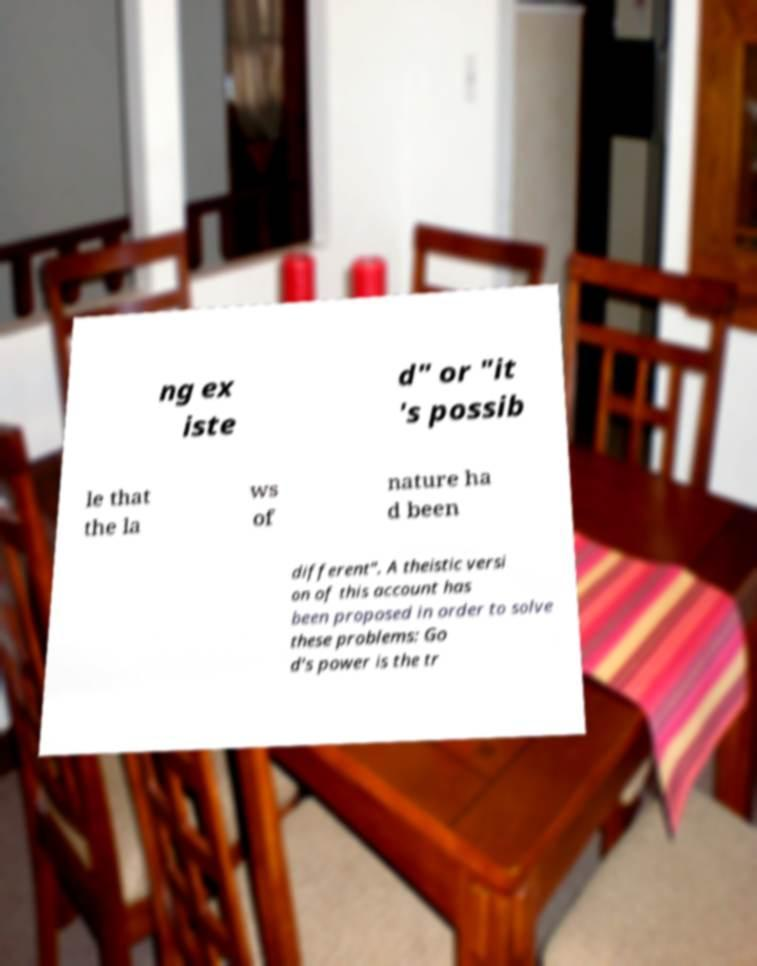Can you read and provide the text displayed in the image?This photo seems to have some interesting text. Can you extract and type it out for me? ng ex iste d" or "it 's possib le that the la ws of nature ha d been different". A theistic versi on of this account has been proposed in order to solve these problems: Go d's power is the tr 